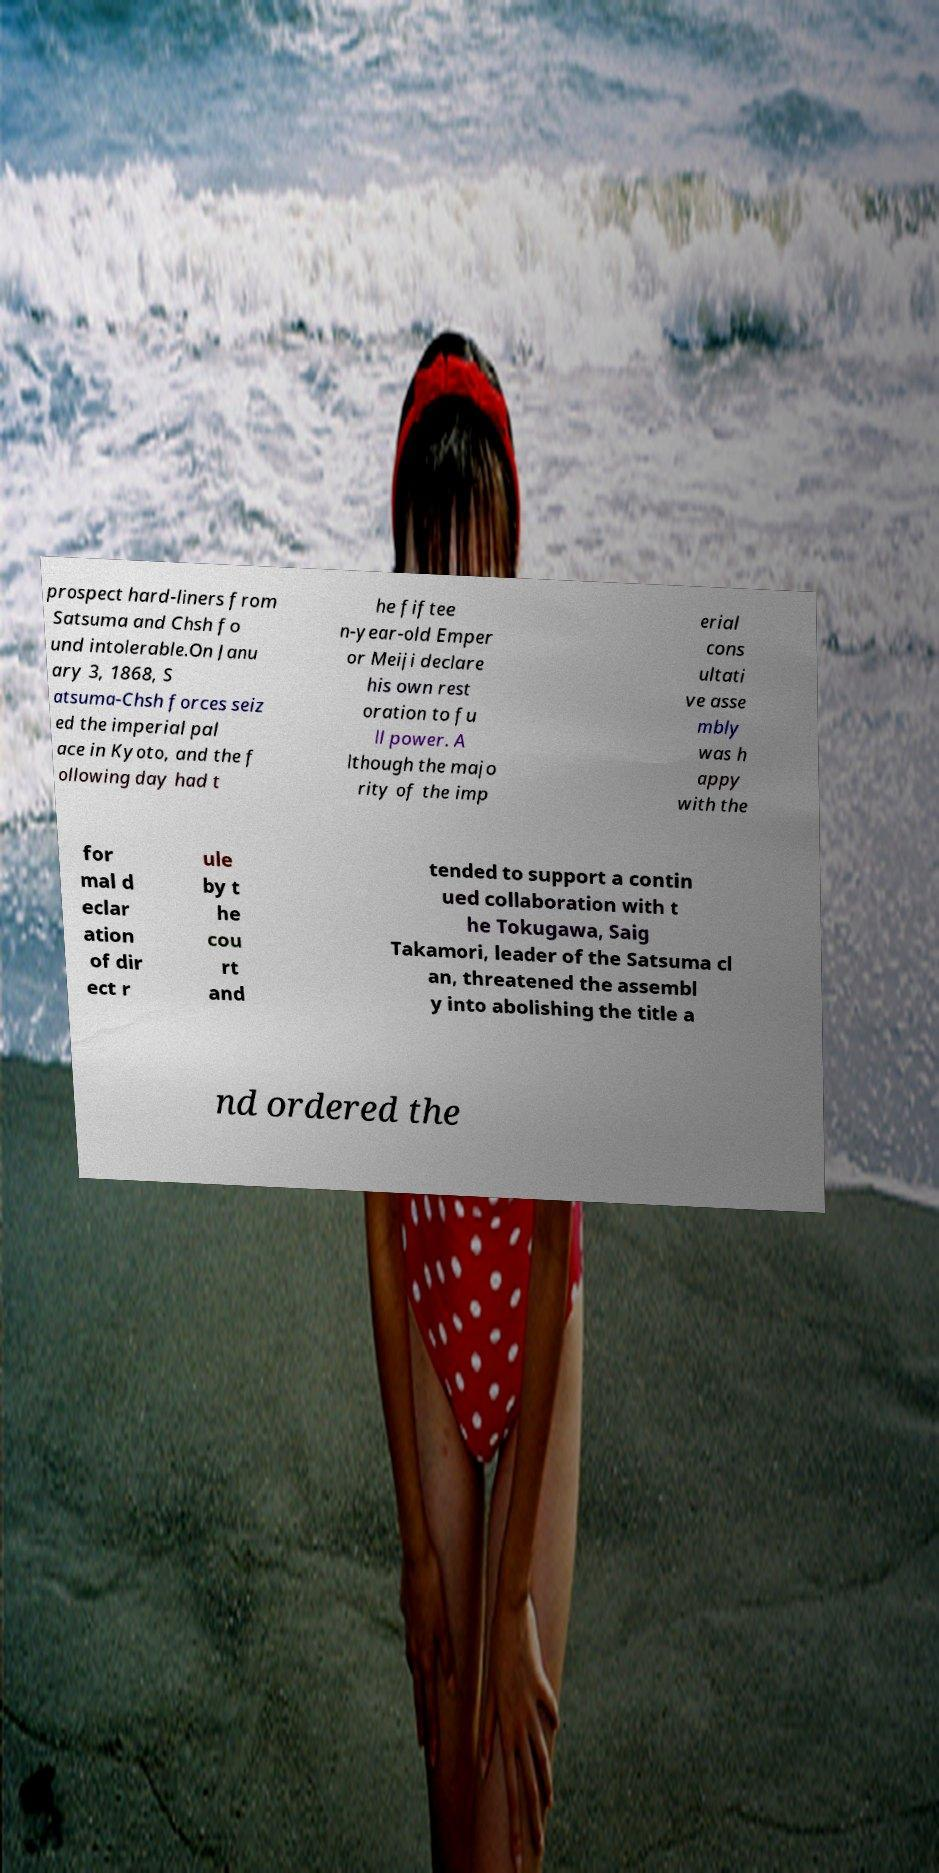Please identify and transcribe the text found in this image. prospect hard-liners from Satsuma and Chsh fo und intolerable.On Janu ary 3, 1868, S atsuma-Chsh forces seiz ed the imperial pal ace in Kyoto, and the f ollowing day had t he fiftee n-year-old Emper or Meiji declare his own rest oration to fu ll power. A lthough the majo rity of the imp erial cons ultati ve asse mbly was h appy with the for mal d eclar ation of dir ect r ule by t he cou rt and tended to support a contin ued collaboration with t he Tokugawa, Saig Takamori, leader of the Satsuma cl an, threatened the assembl y into abolishing the title a nd ordered the 